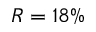Convert formula to latex. <formula><loc_0><loc_0><loc_500><loc_500>R = 1 8 \%</formula> 